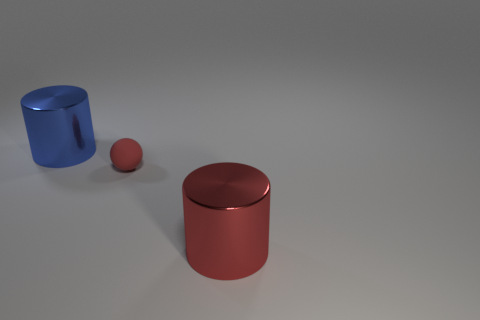Add 2 red rubber spheres. How many red rubber spheres exist? 3 Add 1 large red things. How many objects exist? 4 Subtract all red cylinders. How many cylinders are left? 1 Subtract 1 red cylinders. How many objects are left? 2 Subtract all balls. How many objects are left? 2 Subtract 1 balls. How many balls are left? 0 Subtract all purple cylinders. Subtract all purple balls. How many cylinders are left? 2 Subtract all yellow blocks. How many blue spheres are left? 0 Subtract all blue cylinders. Subtract all red cylinders. How many objects are left? 1 Add 2 tiny red spheres. How many tiny red spheres are left? 3 